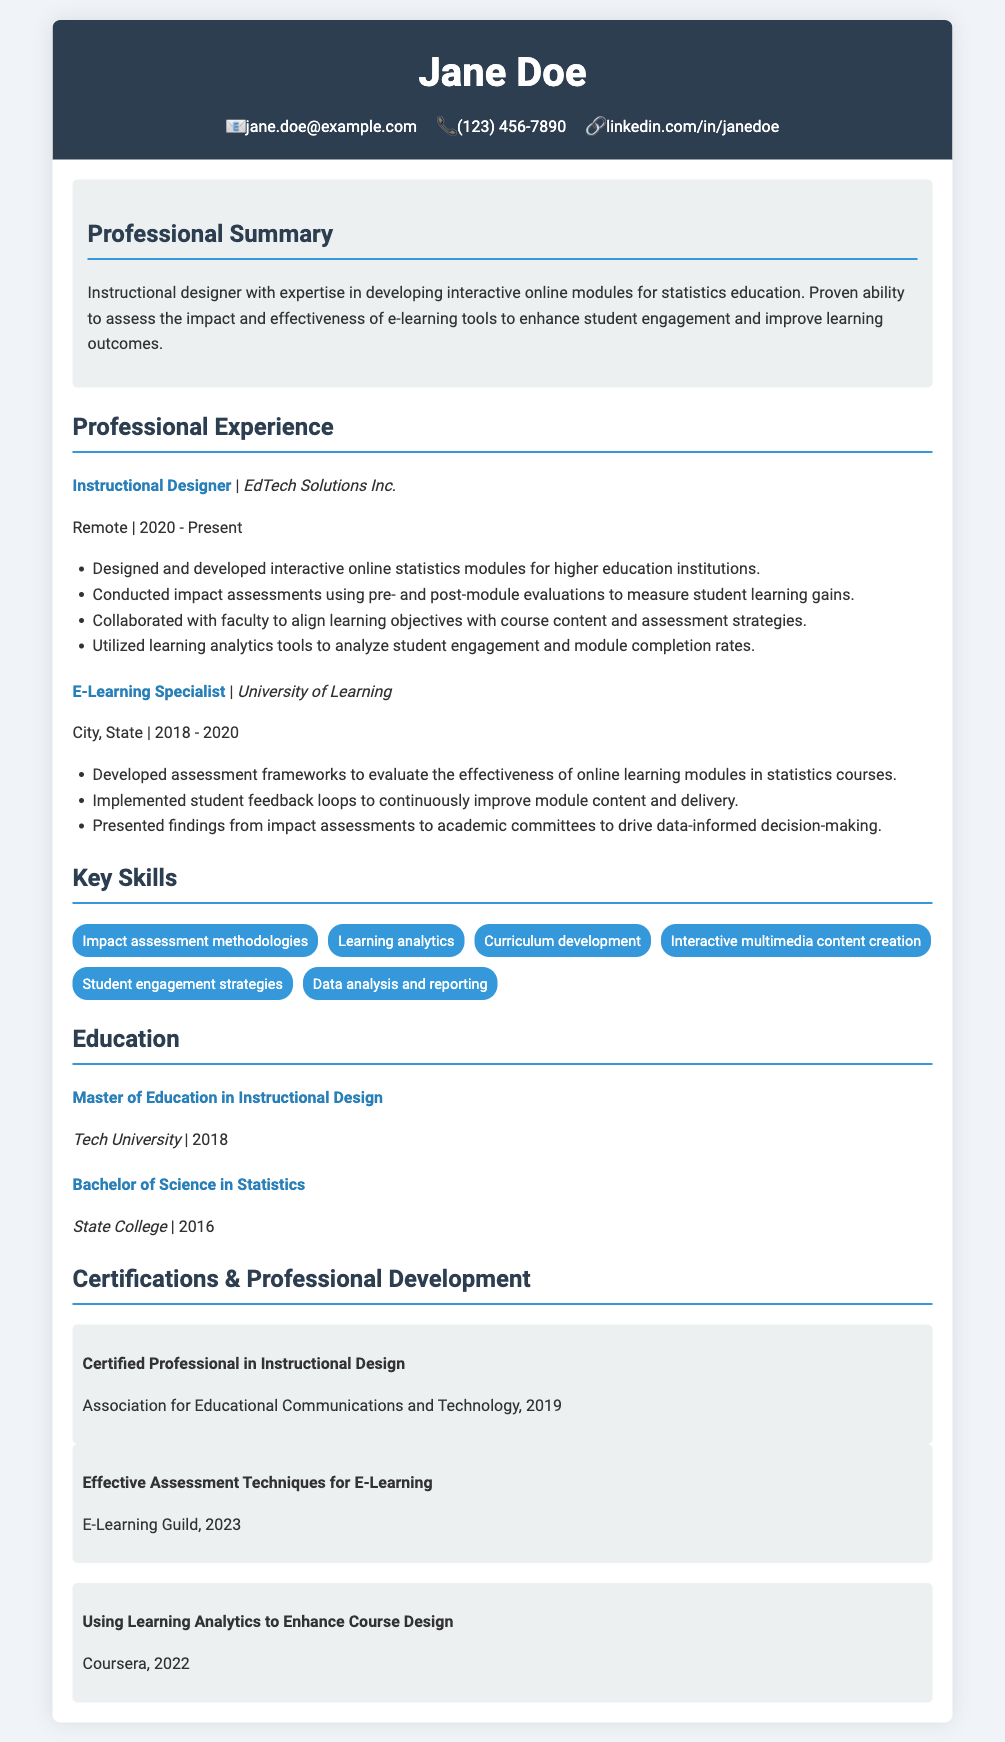What is the name of the instructional designer? The name of the instructional designer is presented in the header of the resume.
Answer: Jane Doe What year did Jane receive her Master of Education? The year of her degree is listed under the education section of the resume.
Answer: 2018 What role did Jane hold at EdTech Solutions Inc.? The job title is found in the professional experience section of the resume.
Answer: Instructional Designer How many years of experience does Jane have in instructional design? The time period mentioned indicates her current role since 2020.
Answer: 3 years Which university did Jane attend for her Bachelor of Science? The specific institution is listed in the education section of the resume.
Answer: State College What type of assessments did Jane implement at the University of Learning? The type is indicated in her responsibilities listed under her role in the professional experience section.
Answer: Student feedback loops Which skill relates to analyzing student engagement? This skill is explicitly mentioned in the key skills section of the resume.
Answer: Learning analytics In what year did Jane complete her certification in instructional design? The year of her certification is included in the certifications section of the resume.
Answer: 2019 What is the title of Jane's current position? The title is found in the professional experience section of the resume.
Answer: Instructional Designer 